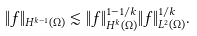<formula> <loc_0><loc_0><loc_500><loc_500>\| f \| _ { H ^ { k - 1 } ( \Omega ) } \lesssim \| f \| _ { H ^ { k } ( \Omega ) } ^ { 1 - 1 / k } \| f \| _ { L ^ { 2 } ( \Omega ) } ^ { 1 / k } .</formula> 